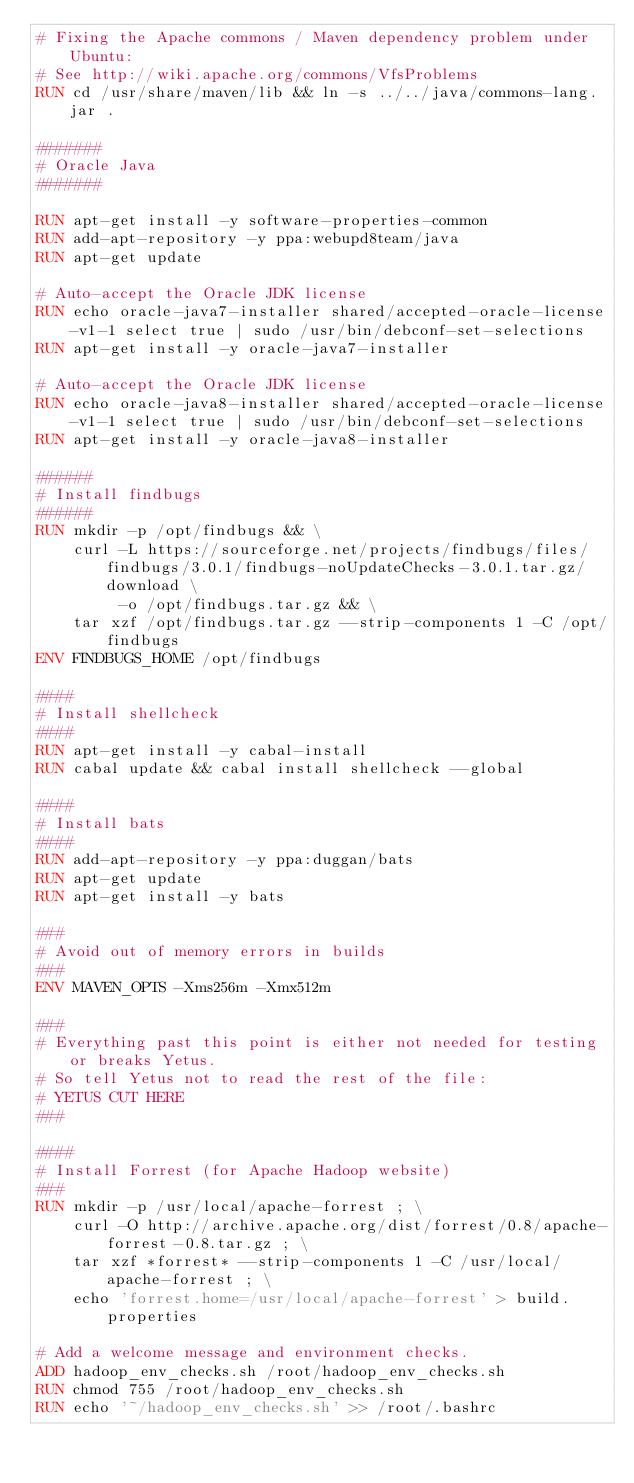Convert code to text. <code><loc_0><loc_0><loc_500><loc_500><_Dockerfile_># Fixing the Apache commons / Maven dependency problem under Ubuntu:
# See http://wiki.apache.org/commons/VfsProblems
RUN cd /usr/share/maven/lib && ln -s ../../java/commons-lang.jar .

#######
# Oracle Java
#######

RUN apt-get install -y software-properties-common
RUN add-apt-repository -y ppa:webupd8team/java
RUN apt-get update

# Auto-accept the Oracle JDK license
RUN echo oracle-java7-installer shared/accepted-oracle-license-v1-1 select true | sudo /usr/bin/debconf-set-selections
RUN apt-get install -y oracle-java7-installer

# Auto-accept the Oracle JDK license
RUN echo oracle-java8-installer shared/accepted-oracle-license-v1-1 select true | sudo /usr/bin/debconf-set-selections
RUN apt-get install -y oracle-java8-installer

######
# Install findbugs
######
RUN mkdir -p /opt/findbugs && \
    curl -L https://sourceforge.net/projects/findbugs/files/findbugs/3.0.1/findbugs-noUpdateChecks-3.0.1.tar.gz/download \
         -o /opt/findbugs.tar.gz && \
    tar xzf /opt/findbugs.tar.gz --strip-components 1 -C /opt/findbugs
ENV FINDBUGS_HOME /opt/findbugs

####
# Install shellcheck
####
RUN apt-get install -y cabal-install
RUN cabal update && cabal install shellcheck --global

####
# Install bats
####
RUN add-apt-repository -y ppa:duggan/bats
RUN apt-get update
RUN apt-get install -y bats

###
# Avoid out of memory errors in builds
###
ENV MAVEN_OPTS -Xms256m -Xmx512m

###
# Everything past this point is either not needed for testing or breaks Yetus.
# So tell Yetus not to read the rest of the file:
# YETUS CUT HERE
###

####
# Install Forrest (for Apache Hadoop website)
###
RUN mkdir -p /usr/local/apache-forrest ; \
    curl -O http://archive.apache.org/dist/forrest/0.8/apache-forrest-0.8.tar.gz ; \
    tar xzf *forrest* --strip-components 1 -C /usr/local/apache-forrest ; \
    echo 'forrest.home=/usr/local/apache-forrest' > build.properties

# Add a welcome message and environment checks.
ADD hadoop_env_checks.sh /root/hadoop_env_checks.sh
RUN chmod 755 /root/hadoop_env_checks.sh
RUN echo '~/hadoop_env_checks.sh' >> /root/.bashrc

</code> 